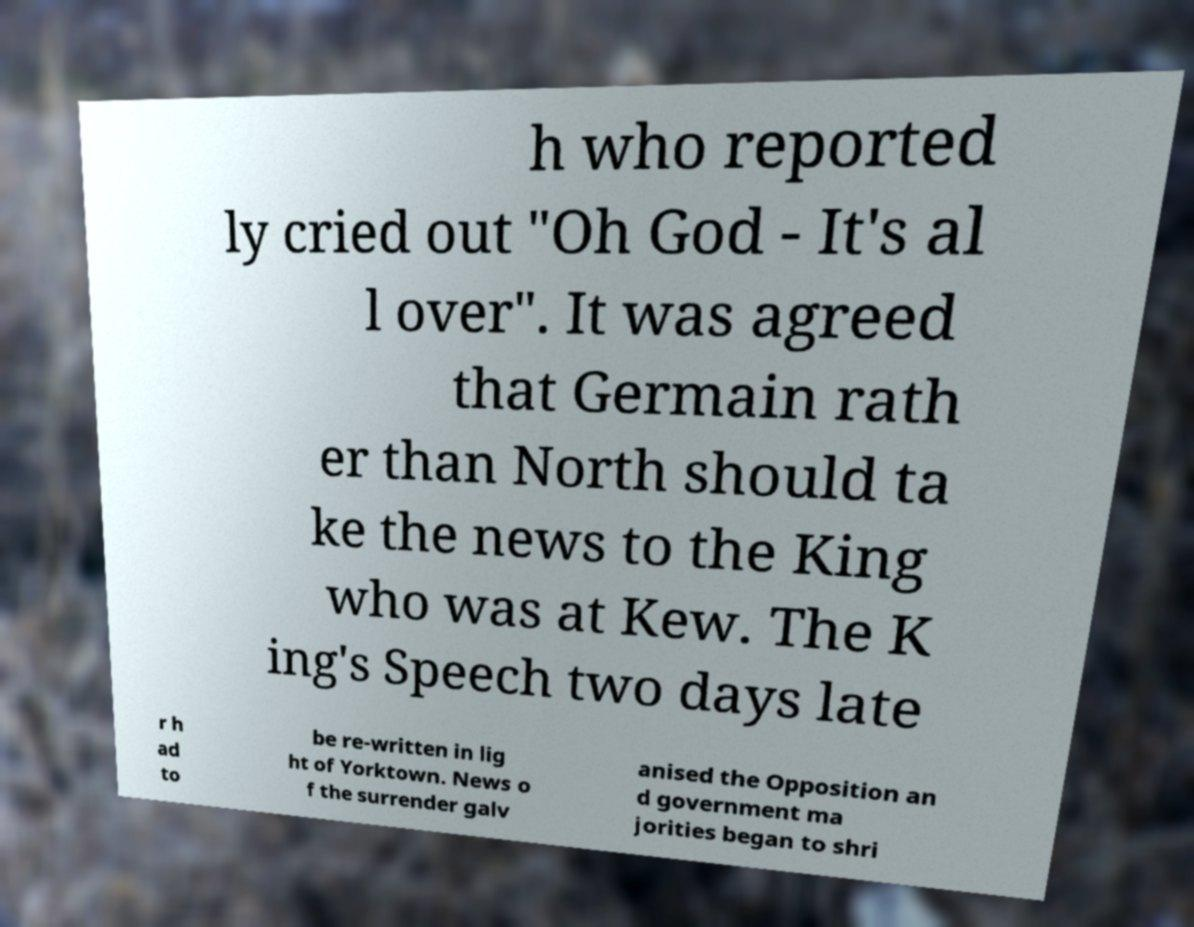I need the written content from this picture converted into text. Can you do that? h who reported ly cried out "Oh God - It's al l over". It was agreed that Germain rath er than North should ta ke the news to the King who was at Kew. The K ing's Speech two days late r h ad to be re-written in lig ht of Yorktown. News o f the surrender galv anised the Opposition an d government ma jorities began to shri 